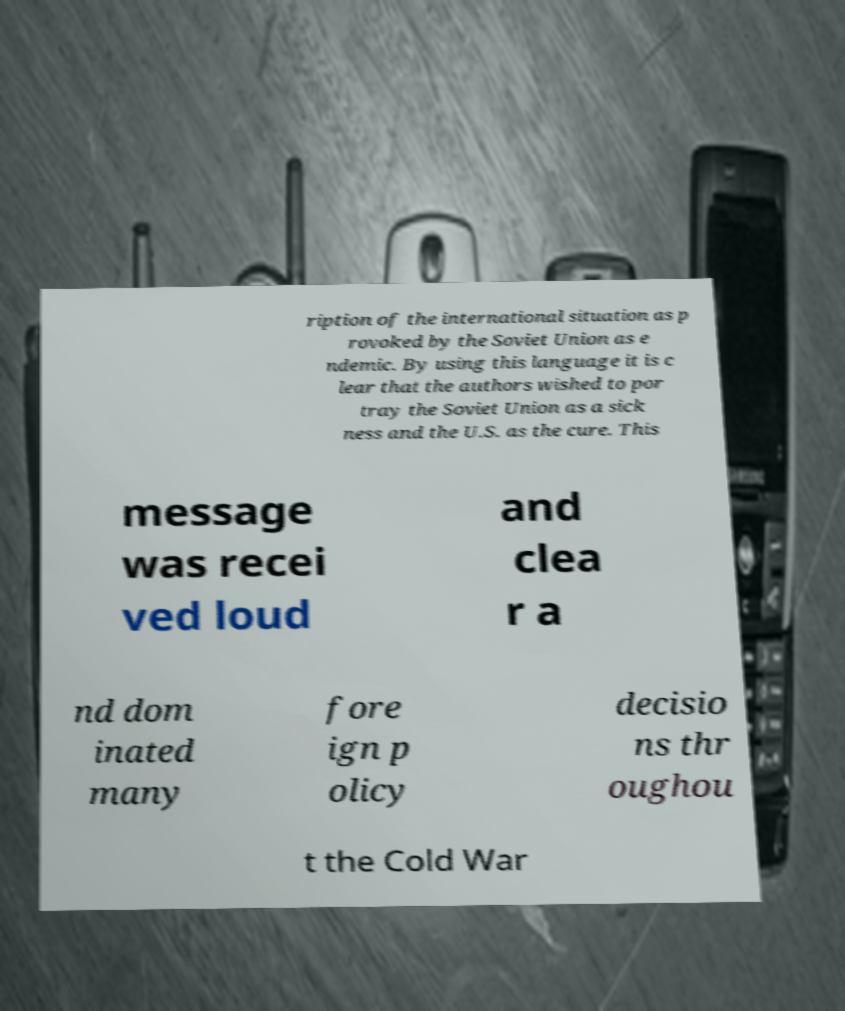What messages or text are displayed in this image? I need them in a readable, typed format. ription of the international situation as p rovoked by the Soviet Union as e ndemic. By using this language it is c lear that the authors wished to por tray the Soviet Union as a sick ness and the U.S. as the cure. This message was recei ved loud and clea r a nd dom inated many fore ign p olicy decisio ns thr oughou t the Cold War 